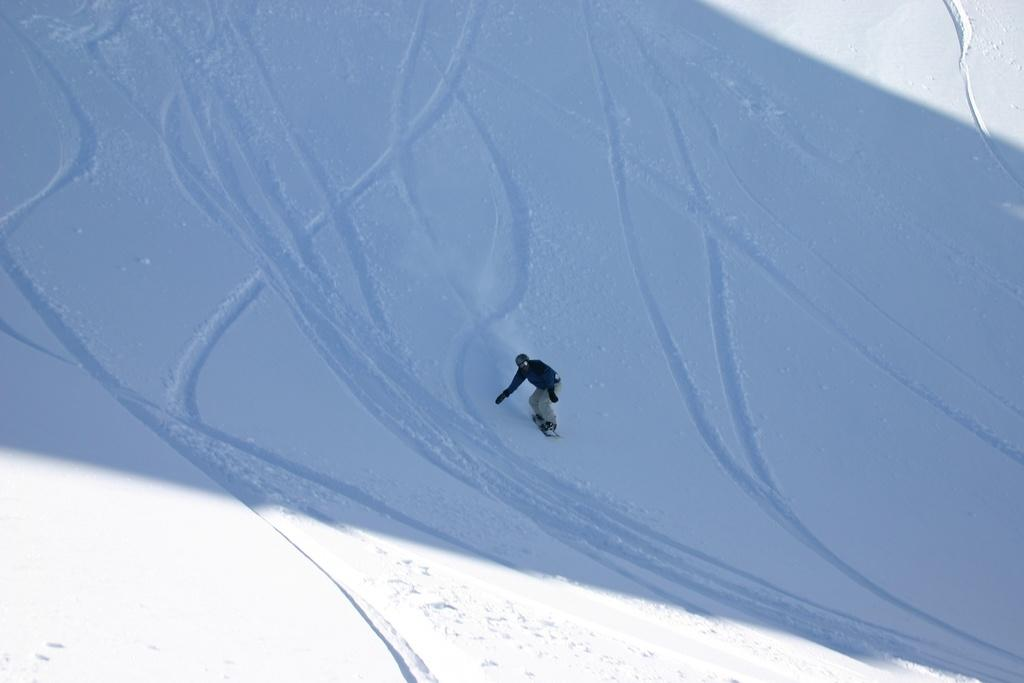Who is present in the image? There is a man in the image. What is the man wearing? The man is wearing a black jacket. What activity is the man engaged in? The man is snowboarding. What type of environment is depicted in the image? There is snow visible in the background of the image. What type of teeth can be seen in the image? There are no teeth visible in the image, as it features a man snowboarding in a snowy environment. What type of frame surrounds the image? The provided facts do not mention any frame surrounding the image, so it cannot be determined. 